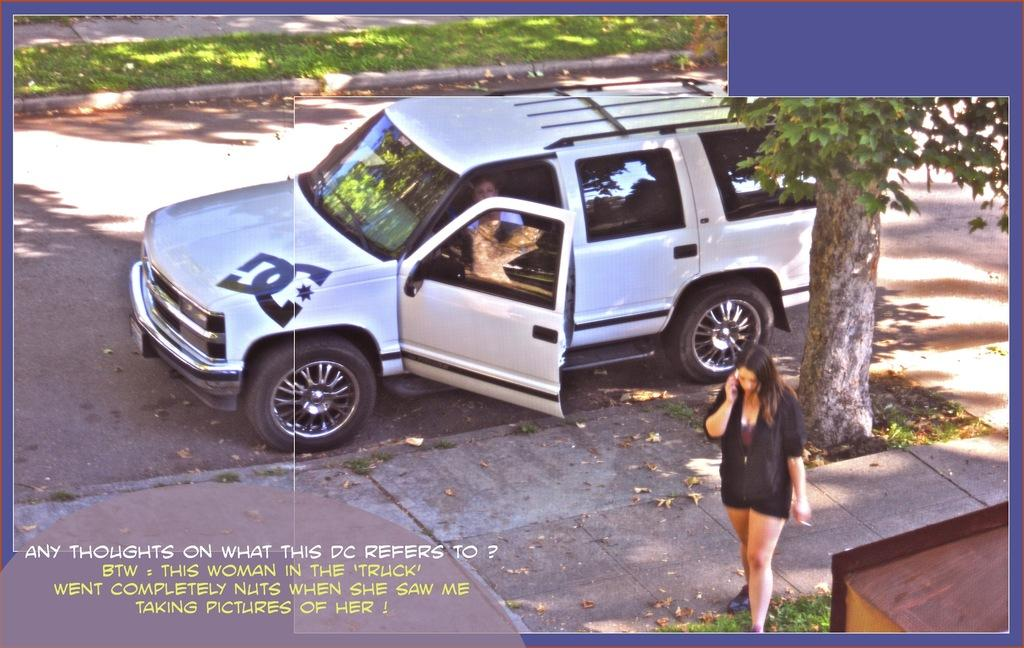What is the woman in the image doing? The woman is sitting in a white vehicle. Where is the vehicle located? The vehicle is on the road. Is there anyone else with the woman in the vehicle? No, there is another woman standing beside the vehicle. What is the standing woman doing? The standing woman is speaking on a mobile phone. Can you tell me the income of the woman sitting in the vehicle? There is no information about the income of the woman in the image. 